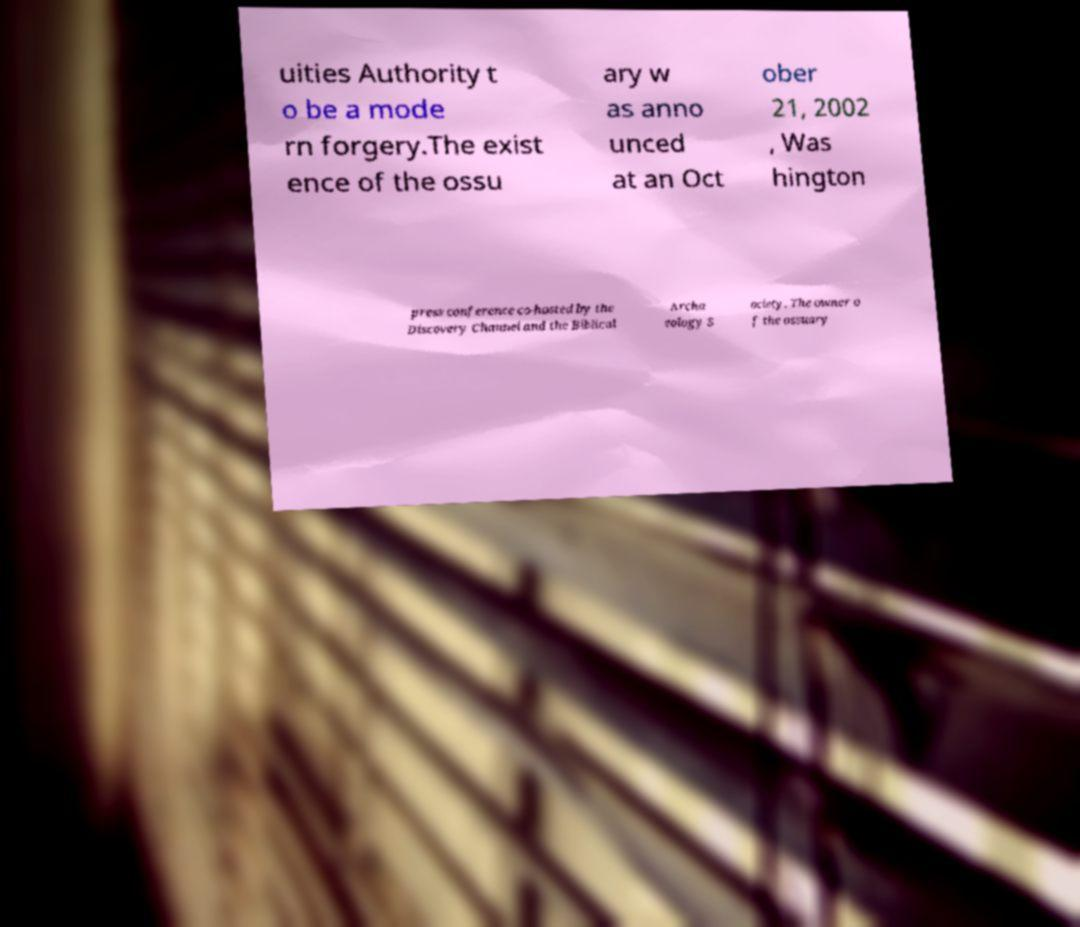Could you extract and type out the text from this image? uities Authority t o be a mode rn forgery.The exist ence of the ossu ary w as anno unced at an Oct ober 21, 2002 , Was hington press conference co-hosted by the Discovery Channel and the Biblical Archa eology S ociety. The owner o f the ossuary 